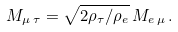<formula> <loc_0><loc_0><loc_500><loc_500>M _ { \mu \, \tau } = \sqrt { 2 \rho _ { \tau } / \rho _ { e } } \, M _ { e \, \mu } \, .</formula> 